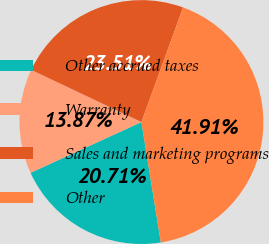Convert chart. <chart><loc_0><loc_0><loc_500><loc_500><pie_chart><fcel>Other accrued taxes<fcel>Warranty<fcel>Sales and marketing programs<fcel>Other<nl><fcel>20.71%<fcel>13.87%<fcel>23.51%<fcel>41.91%<nl></chart> 